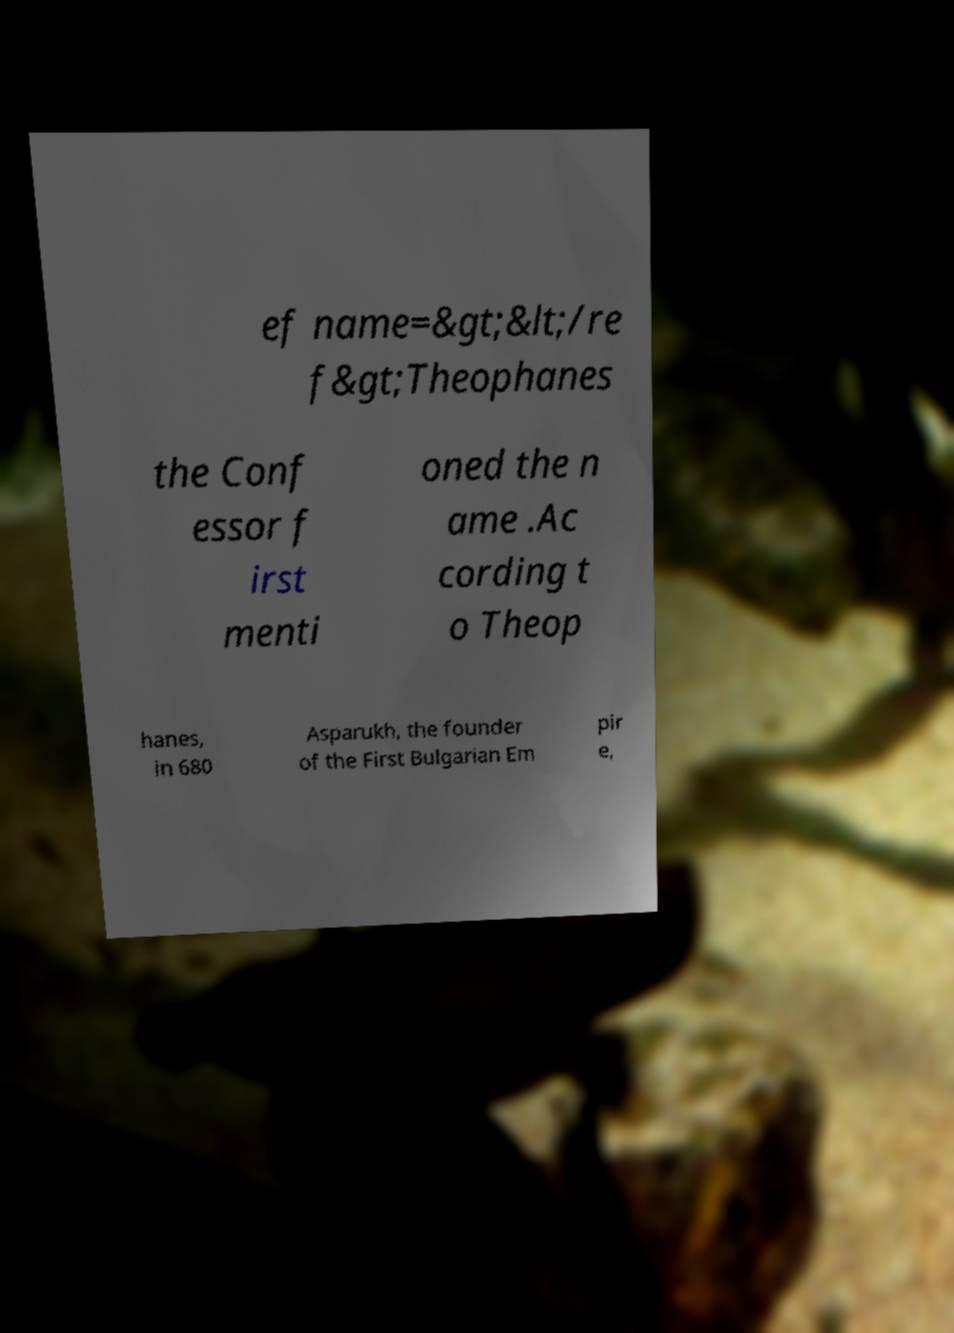Can you read and provide the text displayed in the image?This photo seems to have some interesting text. Can you extract and type it out for me? ef name=&gt;&lt;/re f&gt;Theophanes the Conf essor f irst menti oned the n ame .Ac cording t o Theop hanes, in 680 Asparukh, the founder of the First Bulgarian Em pir e, 